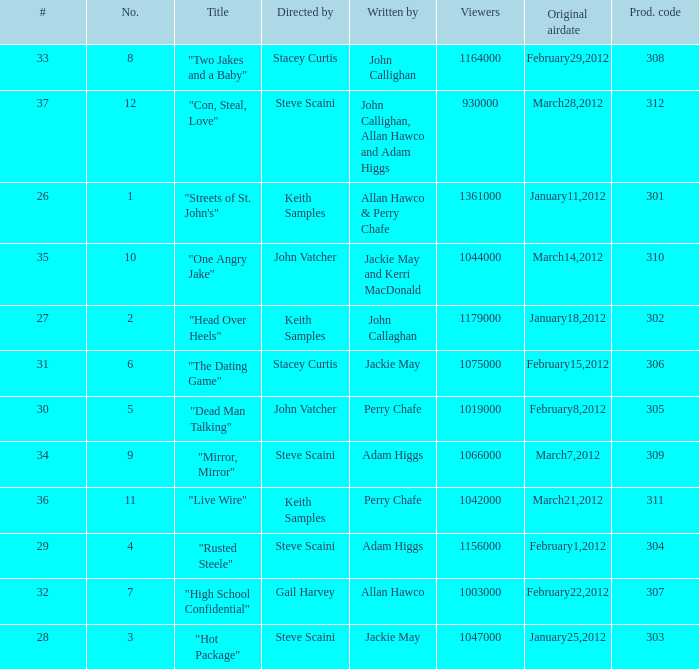Parse the full table. {'header': ['#', 'No.', 'Title', 'Directed by', 'Written by', 'Viewers', 'Original airdate', 'Prod. code'], 'rows': [['33', '8', '"Two Jakes and a Baby"', 'Stacey Curtis', 'John Callighan', '1164000', 'February29,2012', '308'], ['37', '12', '"Con, Steal, Love"', 'Steve Scaini', 'John Callighan, Allan Hawco and Adam Higgs', '930000', 'March28,2012', '312'], ['26', '1', '"Streets of St. John\'s"', 'Keith Samples', 'Allan Hawco & Perry Chafe', '1361000', 'January11,2012', '301'], ['35', '10', '"One Angry Jake"', 'John Vatcher', 'Jackie May and Kerri MacDonald', '1044000', 'March14,2012', '310'], ['27', '2', '"Head Over Heels"', 'Keith Samples', 'John Callaghan', '1179000', 'January18,2012', '302'], ['31', '6', '"The Dating Game"', 'Stacey Curtis', 'Jackie May', '1075000', 'February15,2012', '306'], ['30', '5', '"Dead Man Talking"', 'John Vatcher', 'Perry Chafe', '1019000', 'February8,2012', '305'], ['34', '9', '"Mirror, Mirror"', 'Steve Scaini', 'Adam Higgs', '1066000', 'March7,2012', '309'], ['36', '11', '"Live Wire"', 'Keith Samples', 'Perry Chafe', '1042000', 'March21,2012', '311'], ['29', '4', '"Rusted Steele"', 'Steve Scaini', 'Adam Higgs', '1156000', 'February1,2012', '304'], ['32', '7', '"High School Confidential"', 'Gail Harvey', 'Allan Hawco', '1003000', 'February22,2012', '307'], ['28', '3', '"Hot Package"', 'Steve Scaini', 'Jackie May', '1047000', 'January25,2012', '303']]} What is the quantity of original airdate authored by allan hawco? 1.0. 